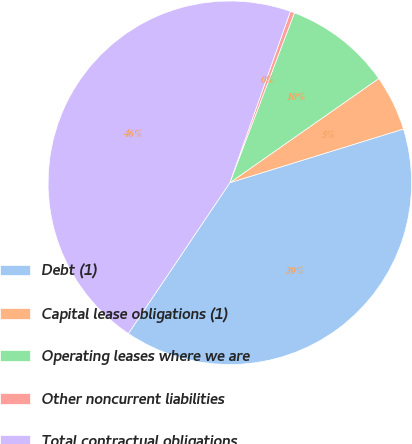<chart> <loc_0><loc_0><loc_500><loc_500><pie_chart><fcel>Debt (1)<fcel>Capital lease obligations (1)<fcel>Operating leases where we are<fcel>Other noncurrent liabilities<fcel>Total contractual obligations<nl><fcel>39.2%<fcel>4.94%<fcel>9.5%<fcel>0.38%<fcel>45.98%<nl></chart> 